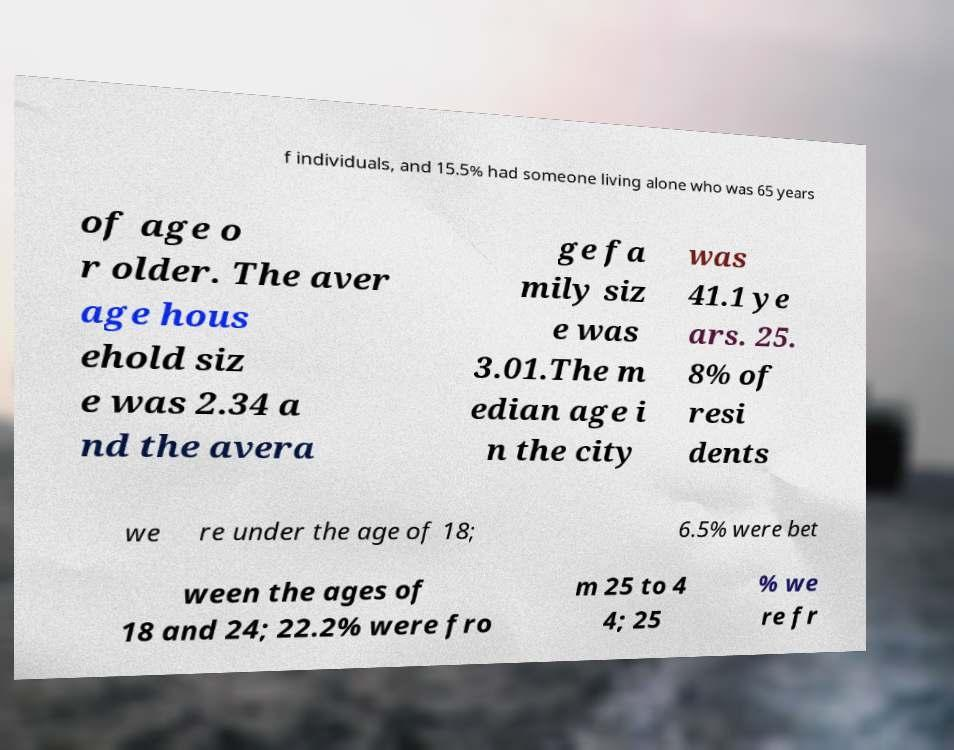What messages or text are displayed in this image? I need them in a readable, typed format. f individuals, and 15.5% had someone living alone who was 65 years of age o r older. The aver age hous ehold siz e was 2.34 a nd the avera ge fa mily siz e was 3.01.The m edian age i n the city was 41.1 ye ars. 25. 8% of resi dents we re under the age of 18; 6.5% were bet ween the ages of 18 and 24; 22.2% were fro m 25 to 4 4; 25 % we re fr 